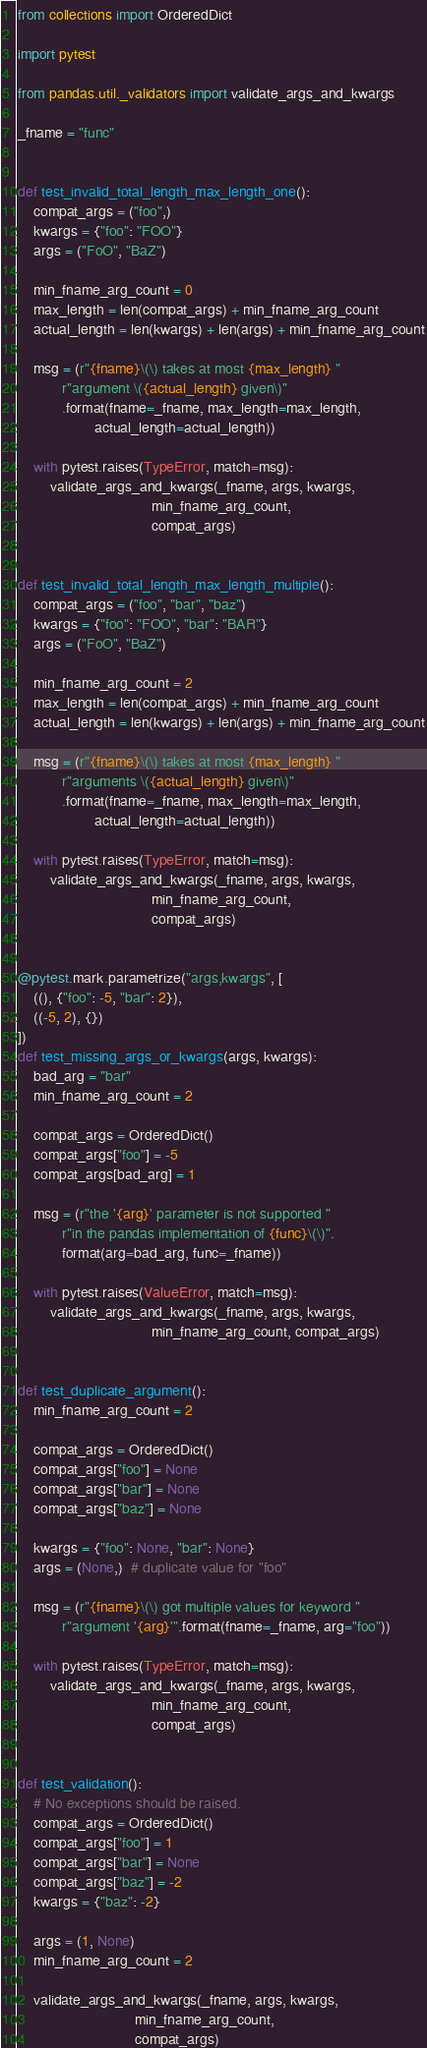<code> <loc_0><loc_0><loc_500><loc_500><_Python_>from collections import OrderedDict

import pytest

from pandas.util._validators import validate_args_and_kwargs

_fname = "func"


def test_invalid_total_length_max_length_one():
    compat_args = ("foo",)
    kwargs = {"foo": "FOO"}
    args = ("FoO", "BaZ")

    min_fname_arg_count = 0
    max_length = len(compat_args) + min_fname_arg_count
    actual_length = len(kwargs) + len(args) + min_fname_arg_count

    msg = (r"{fname}\(\) takes at most {max_length} "
           r"argument \({actual_length} given\)"
           .format(fname=_fname, max_length=max_length,
                   actual_length=actual_length))

    with pytest.raises(TypeError, match=msg):
        validate_args_and_kwargs(_fname, args, kwargs,
                                 min_fname_arg_count,
                                 compat_args)


def test_invalid_total_length_max_length_multiple():
    compat_args = ("foo", "bar", "baz")
    kwargs = {"foo": "FOO", "bar": "BAR"}
    args = ("FoO", "BaZ")

    min_fname_arg_count = 2
    max_length = len(compat_args) + min_fname_arg_count
    actual_length = len(kwargs) + len(args) + min_fname_arg_count

    msg = (r"{fname}\(\) takes at most {max_length} "
           r"arguments \({actual_length} given\)"
           .format(fname=_fname, max_length=max_length,
                   actual_length=actual_length))

    with pytest.raises(TypeError, match=msg):
        validate_args_and_kwargs(_fname, args, kwargs,
                                 min_fname_arg_count,
                                 compat_args)


@pytest.mark.parametrize("args,kwargs", [
    ((), {"foo": -5, "bar": 2}),
    ((-5, 2), {})
])
def test_missing_args_or_kwargs(args, kwargs):
    bad_arg = "bar"
    min_fname_arg_count = 2

    compat_args = OrderedDict()
    compat_args["foo"] = -5
    compat_args[bad_arg] = 1

    msg = (r"the '{arg}' parameter is not supported "
           r"in the pandas implementation of {func}\(\)".
           format(arg=bad_arg, func=_fname))

    with pytest.raises(ValueError, match=msg):
        validate_args_and_kwargs(_fname, args, kwargs,
                                 min_fname_arg_count, compat_args)


def test_duplicate_argument():
    min_fname_arg_count = 2

    compat_args = OrderedDict()
    compat_args["foo"] = None
    compat_args["bar"] = None
    compat_args["baz"] = None

    kwargs = {"foo": None, "bar": None}
    args = (None,)  # duplicate value for "foo"

    msg = (r"{fname}\(\) got multiple values for keyword "
           r"argument '{arg}'".format(fname=_fname, arg="foo"))

    with pytest.raises(TypeError, match=msg):
        validate_args_and_kwargs(_fname, args, kwargs,
                                 min_fname_arg_count,
                                 compat_args)


def test_validation():
    # No exceptions should be raised.
    compat_args = OrderedDict()
    compat_args["foo"] = 1
    compat_args["bar"] = None
    compat_args["baz"] = -2
    kwargs = {"baz": -2}

    args = (1, None)
    min_fname_arg_count = 2

    validate_args_and_kwargs(_fname, args, kwargs,
                             min_fname_arg_count,
                             compat_args)
</code> 